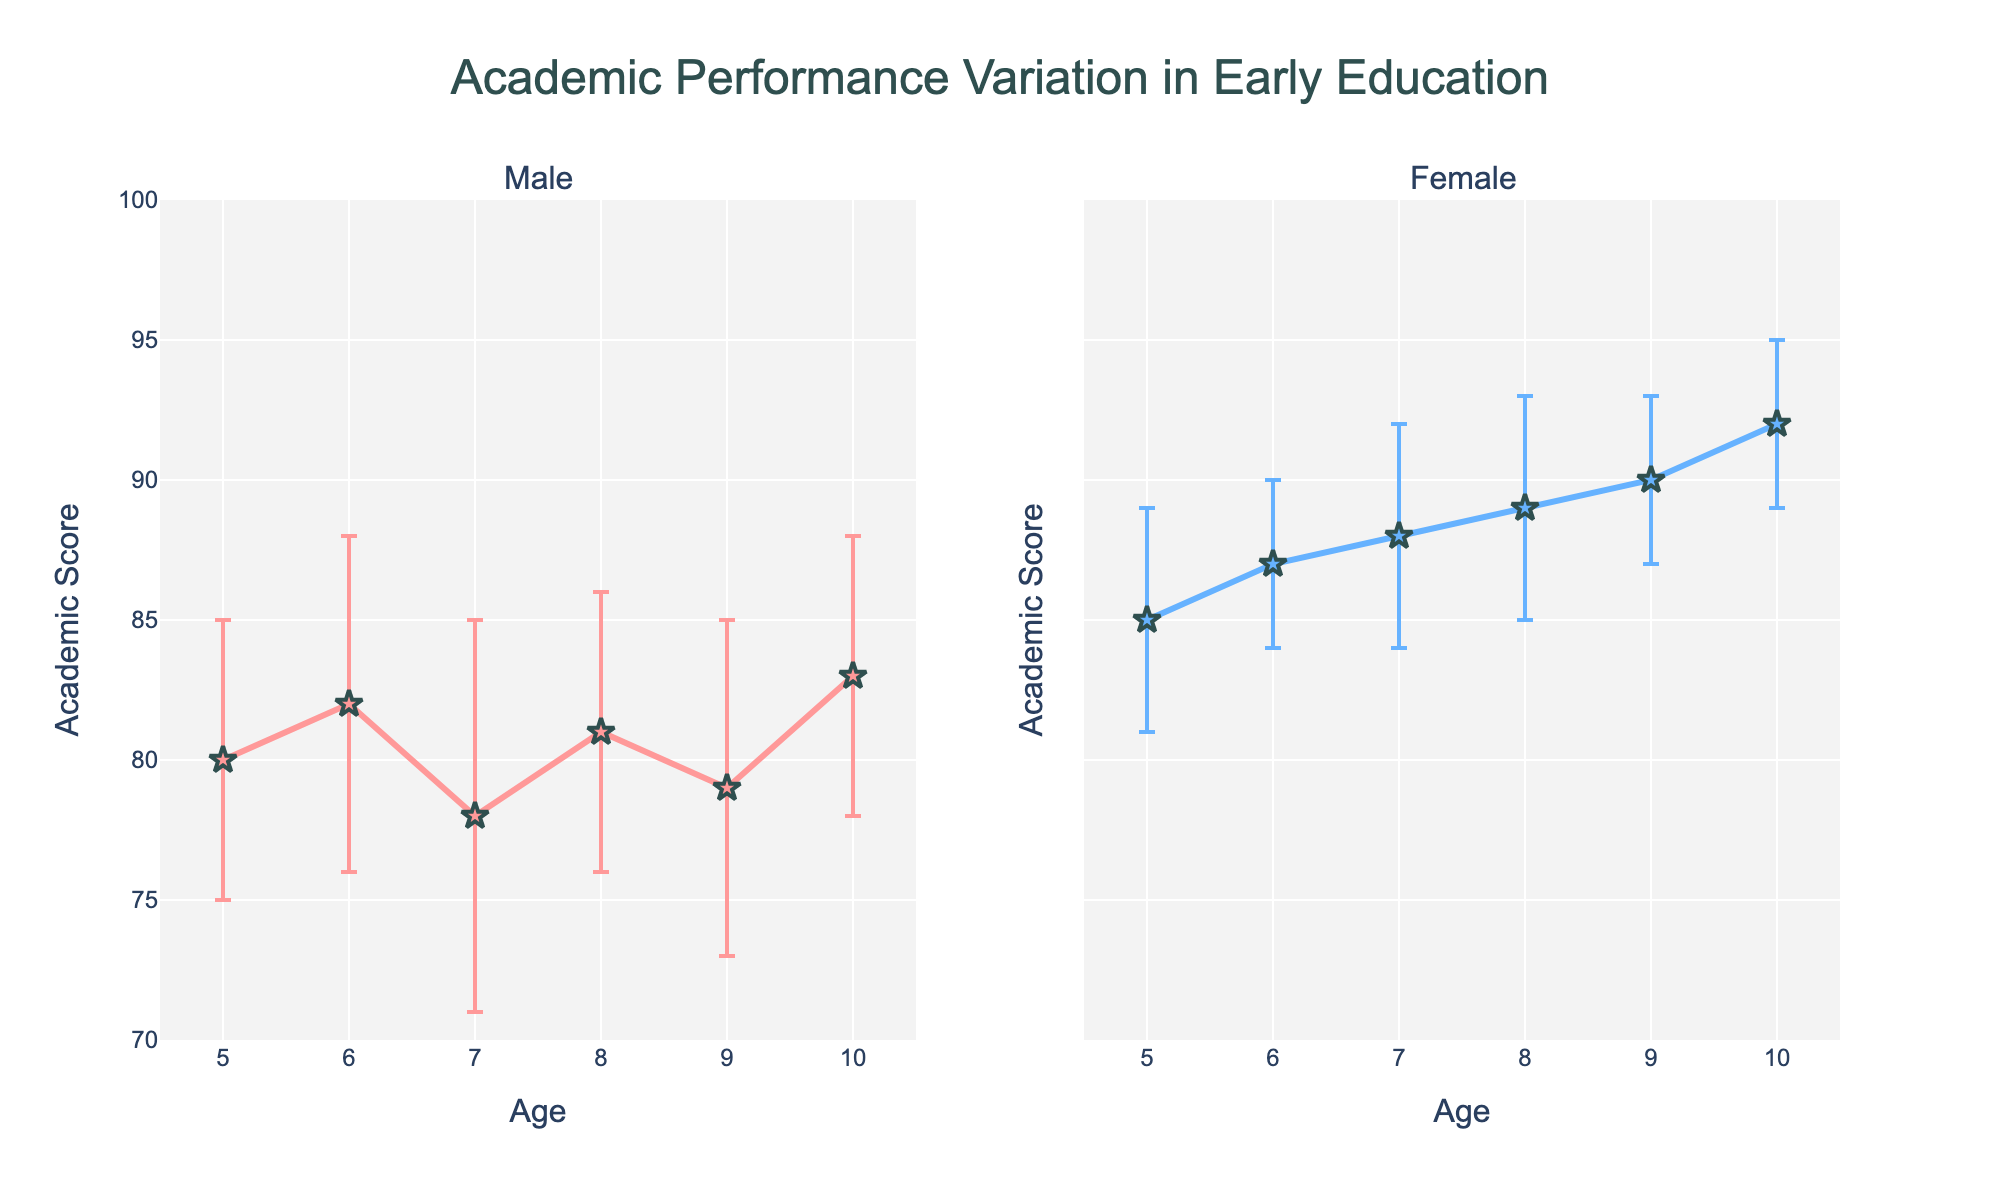What is the title of the plot? The plot's title is shown at the top, which summarizes the content clearly.
Answer: Academic Performance Variation in Early Education What is the academic score for 6-year-old girls? Find the point on the plot where Age is 6 and Gender is Female.
Answer: 87 Which gender has the higher average academic score? Add the scores and divide by the number of data points for each gender. For Female: (85+87+88+89+90+92)/6 = 88.5. For Male: (80+82+78+81+79+83)/6 = 80.5. Compare the averages.
Answer: Female What is the age range presented in the plot? Look at the x-axis to find the minimum and maximum ages.
Answer: 5 to 10 At which age is the difference in academic scores between boys and girls the largest? Subtract the boys' scores from the girls' scores for each age and find the age with the largest difference. Differences: 5 (5), 6 (5), 7 (10), 8 (8), 9 (11), 10 (9).
Answer: 9 What shape are the markers used in the plot? Observe the shape of the markers for both subplots.
Answer: Star What age has the highest academic score for girls? Look at the scores for the Female subplot and identify the highest value.
Answer: 10 Which gender shows more variability in academic scores? Look at the error bars. Longer error bars indicate higher variability. Compare the length of error bars for both genders.
Answer: Male What is the academic score for 5-year-old boys? Find the point on the plot where Age is 5 and Gender is Male.
Answer: 80 Does any gender have a consistent increase in academic scores with age? Check the trend of scores for both genders as age increases to see if the scores continually increase.
Answer: Female 